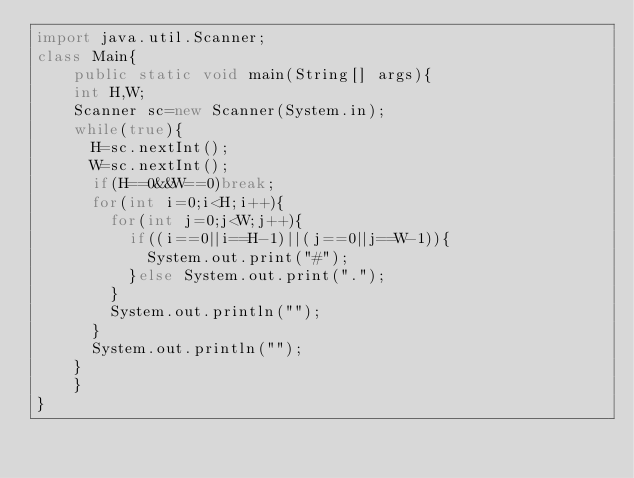Convert code to text. <code><loc_0><loc_0><loc_500><loc_500><_Java_>import java.util.Scanner;
class Main{
    public static void main(String[] args){
		int H,W;
		Scanner sc=new Scanner(System.in);
		while(true){
			H=sc.nextInt();
			W=sc.nextInt();
			if(H==0&&W==0)break;
			for(int i=0;i<H;i++){
				for(int j=0;j<W;j++){
					if((i==0||i==H-1)||(j==0||j==W-1)){
						System.out.print("#");
					}else System.out.print(".");
				}
				System.out.println("");
			}
			System.out.println("");
		}
    }
}

</code> 